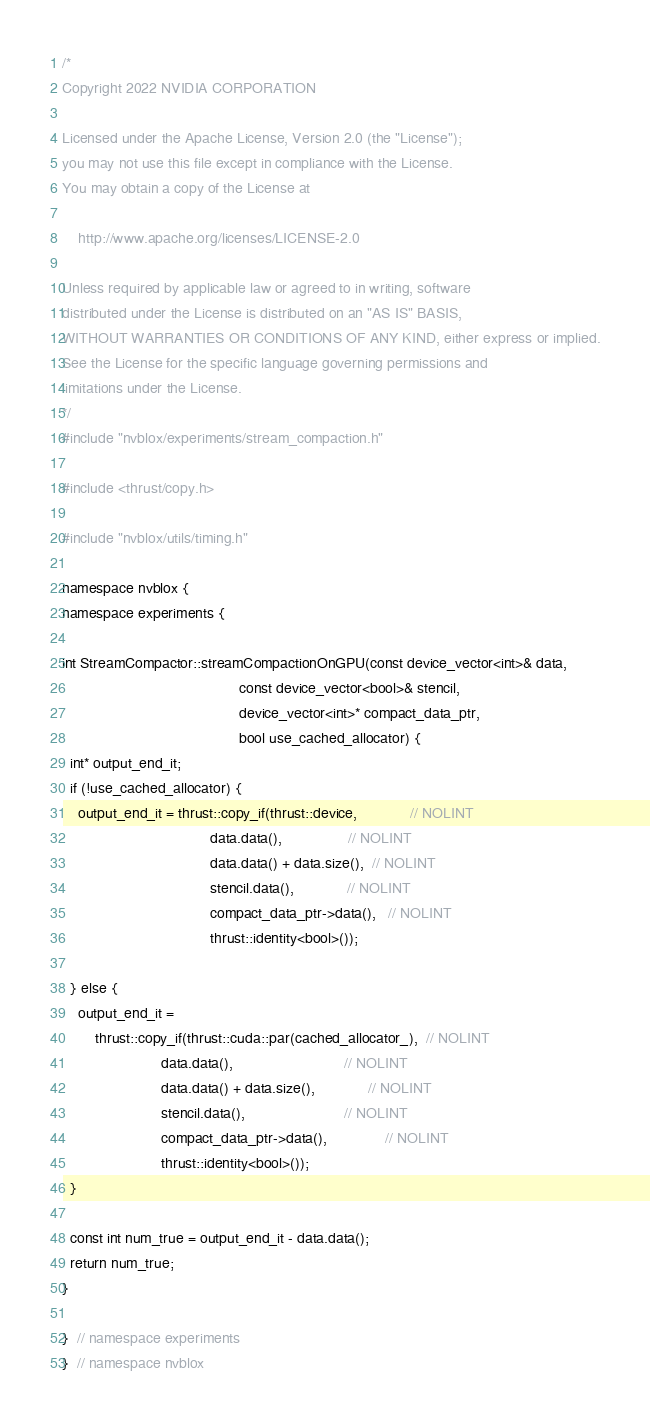Convert code to text. <code><loc_0><loc_0><loc_500><loc_500><_Cuda_>/*
Copyright 2022 NVIDIA CORPORATION

Licensed under the Apache License, Version 2.0 (the "License");
you may not use this file except in compliance with the License.
You may obtain a copy of the License at

    http://www.apache.org/licenses/LICENSE-2.0

Unless required by applicable law or agreed to in writing, software
distributed under the License is distributed on an "AS IS" BASIS,
WITHOUT WARRANTIES OR CONDITIONS OF ANY KIND, either express or implied.
See the License for the specific language governing permissions and
limitations under the License.
*/
#include "nvblox/experiments/stream_compaction.h"

#include <thrust/copy.h>

#include "nvblox/utils/timing.h"

namespace nvblox {
namespace experiments {

int StreamCompactor::streamCompactionOnGPU(const device_vector<int>& data,
                                           const device_vector<bool>& stencil,
                                           device_vector<int>* compact_data_ptr,
                                           bool use_cached_allocator) {
  int* output_end_it;
  if (!use_cached_allocator) {
    output_end_it = thrust::copy_if(thrust::device,             // NOLINT
                                    data.data(),                // NOLINT
                                    data.data() + data.size(),  // NOLINT
                                    stencil.data(),             // NOLINT
                                    compact_data_ptr->data(),   // NOLINT
                                    thrust::identity<bool>());

  } else {
    output_end_it =
        thrust::copy_if(thrust::cuda::par(cached_allocator_),  // NOLINT
                        data.data(),                           // NOLINT
                        data.data() + data.size(),             // NOLINT
                        stencil.data(),                        // NOLINT
                        compact_data_ptr->data(),              // NOLINT
                        thrust::identity<bool>());
  }

  const int num_true = output_end_it - data.data();
  return num_true;
}

}  // namespace experiments
}  // namespace nvblox
</code> 